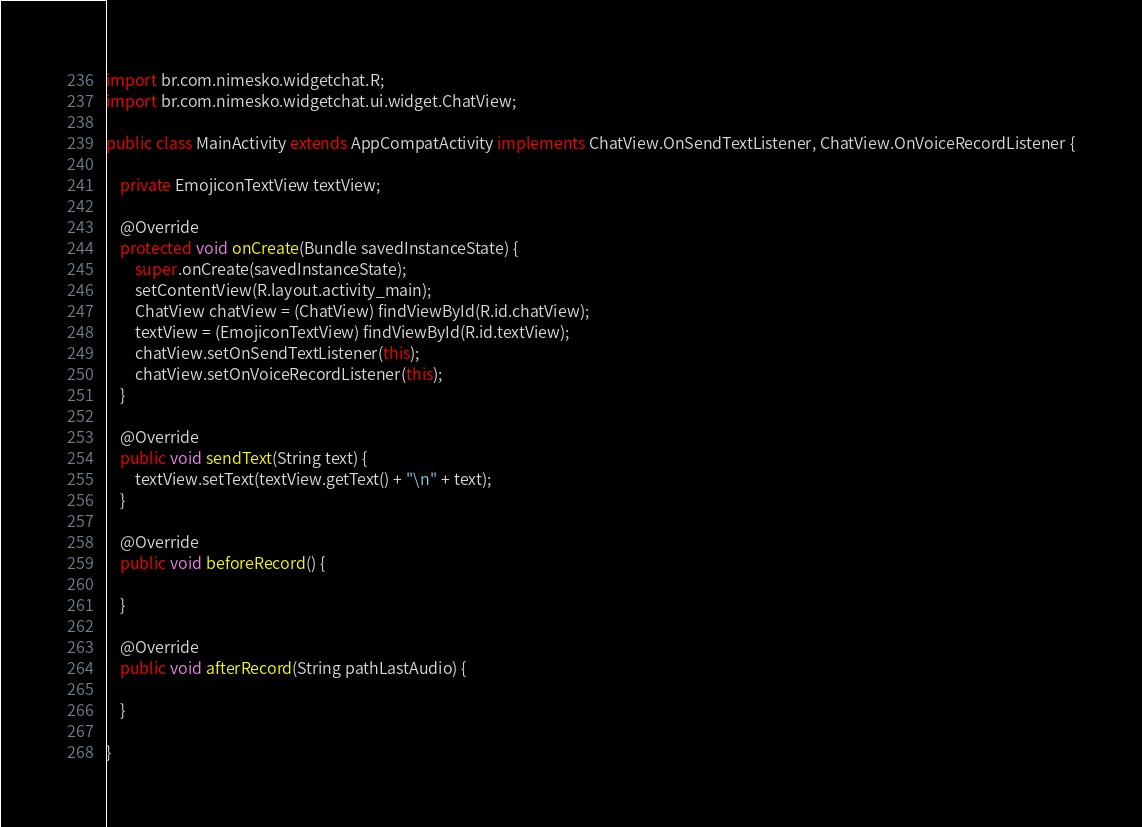<code> <loc_0><loc_0><loc_500><loc_500><_Java_>
import br.com.nimesko.widgetchat.R;
import br.com.nimesko.widgetchat.ui.widget.ChatView;

public class MainActivity extends AppCompatActivity implements ChatView.OnSendTextListener, ChatView.OnVoiceRecordListener {

    private EmojiconTextView textView;

    @Override
    protected void onCreate(Bundle savedInstanceState) {
        super.onCreate(savedInstanceState);
        setContentView(R.layout.activity_main);
        ChatView chatView = (ChatView) findViewById(R.id.chatView);
        textView = (EmojiconTextView) findViewById(R.id.textView);
        chatView.setOnSendTextListener(this);
        chatView.setOnVoiceRecordListener(this);
    }

    @Override
    public void sendText(String text) {
        textView.setText(textView.getText() + "\n" + text);
    }

    @Override
    public void beforeRecord() {

    }

    @Override
    public void afterRecord(String pathLastAudio) {

    }

}
</code> 